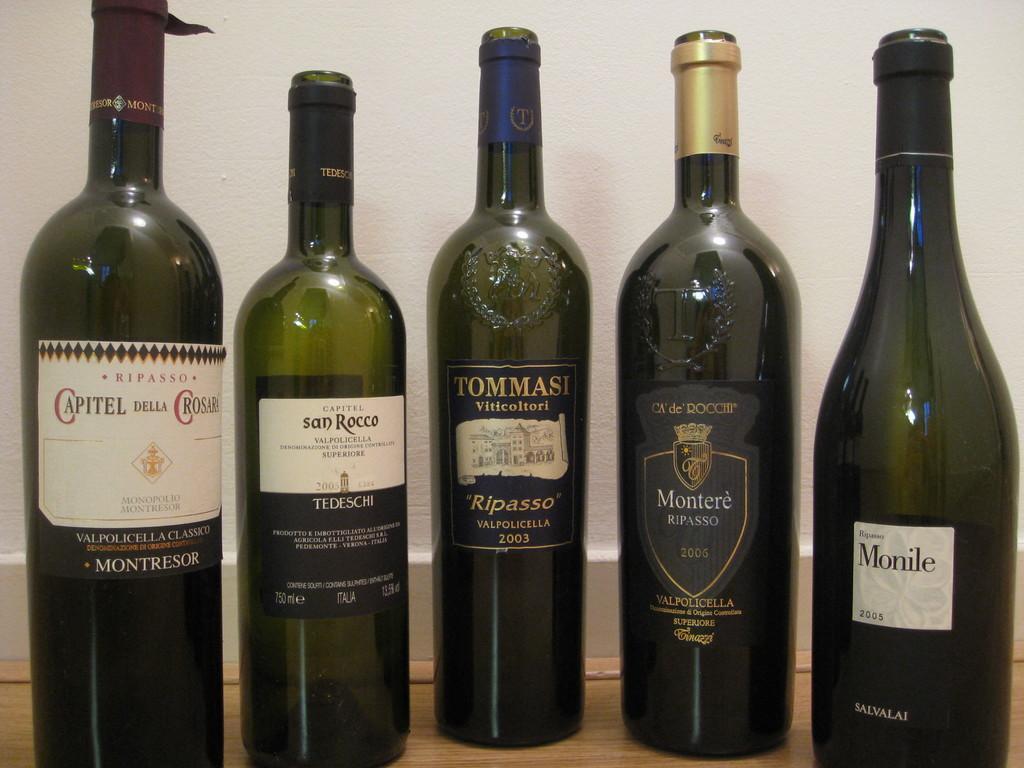How would you summarize this image in a sentence or two? There are five bottles placed on the table. In the background there is a wall. 